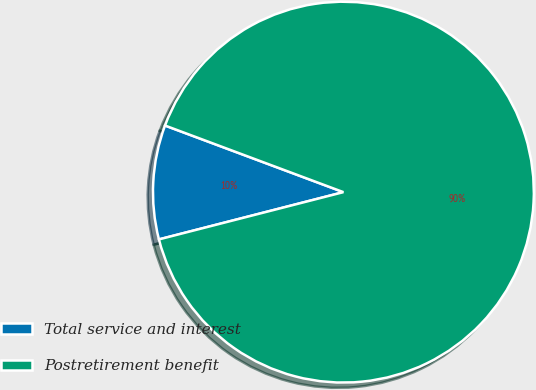Convert chart. <chart><loc_0><loc_0><loc_500><loc_500><pie_chart><fcel>Total service and interest<fcel>Postretirement benefit<nl><fcel>9.68%<fcel>90.32%<nl></chart> 